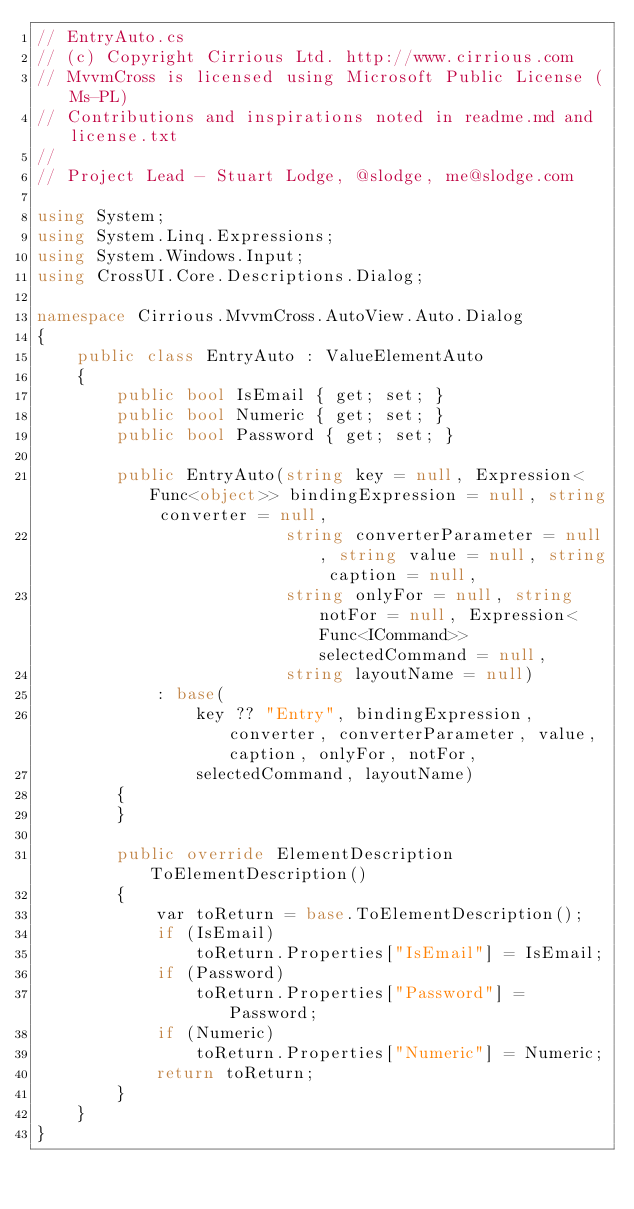Convert code to text. <code><loc_0><loc_0><loc_500><loc_500><_C#_>// EntryAuto.cs
// (c) Copyright Cirrious Ltd. http://www.cirrious.com
// MvvmCross is licensed using Microsoft Public License (Ms-PL)
// Contributions and inspirations noted in readme.md and license.txt
// 
// Project Lead - Stuart Lodge, @slodge, me@slodge.com

using System;
using System.Linq.Expressions;
using System.Windows.Input;
using CrossUI.Core.Descriptions.Dialog;

namespace Cirrious.MvvmCross.AutoView.Auto.Dialog
{
    public class EntryAuto : ValueElementAuto
    {
        public bool IsEmail { get; set; }
        public bool Numeric { get; set; }
        public bool Password { get; set; }

        public EntryAuto(string key = null, Expression<Func<object>> bindingExpression = null, string converter = null,
                         string converterParameter = null, string value = null, string caption = null,
                         string onlyFor = null, string notFor = null, Expression<Func<ICommand>> selectedCommand = null,
                         string layoutName = null)
            : base(
                key ?? "Entry", bindingExpression, converter, converterParameter, value, caption, onlyFor, notFor,
                selectedCommand, layoutName)
        {
        }

        public override ElementDescription ToElementDescription()
        {
            var toReturn = base.ToElementDescription();
            if (IsEmail)
                toReturn.Properties["IsEmail"] = IsEmail;
            if (Password)
                toReturn.Properties["Password"] = Password;
            if (Numeric)
                toReturn.Properties["Numeric"] = Numeric;
            return toReturn;
        }
    }
}</code> 